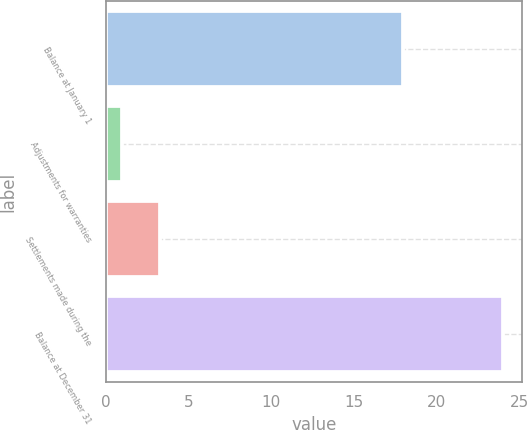Convert chart. <chart><loc_0><loc_0><loc_500><loc_500><bar_chart><fcel>Balance at January 1<fcel>Adjustments for warranties<fcel>Settlements made during the<fcel>Balance at December 31<nl><fcel>18<fcel>1<fcel>3.3<fcel>24<nl></chart> 